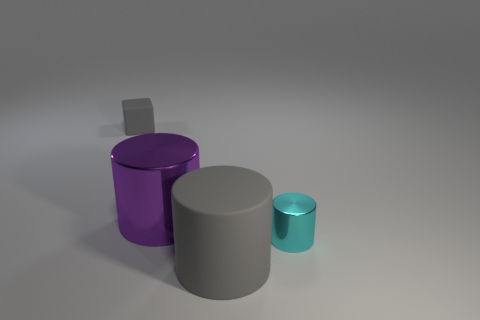Do the tiny rubber object and the large matte cylinder have the same color?
Provide a short and direct response. Yes. What number of matte blocks are the same size as the cyan thing?
Give a very brief answer. 1. What is the material of the gray object to the right of the rubber object that is behind the big cylinder behind the gray rubber cylinder?
Give a very brief answer. Rubber. What number of things are matte cylinders or tiny blue rubber cylinders?
Offer a terse response. 1. What is the shape of the big gray matte thing?
Offer a very short reply. Cylinder. What shape is the gray thing behind the shiny thing that is behind the cyan metal object?
Keep it short and to the point. Cube. Do the gray thing that is in front of the small block and the cyan thing have the same material?
Offer a terse response. No. How many gray objects are small rubber blocks or rubber things?
Provide a short and direct response. 2. Is there a big thing of the same color as the cube?
Offer a terse response. Yes. Is there a big purple cylinder made of the same material as the small cylinder?
Offer a very short reply. Yes. 